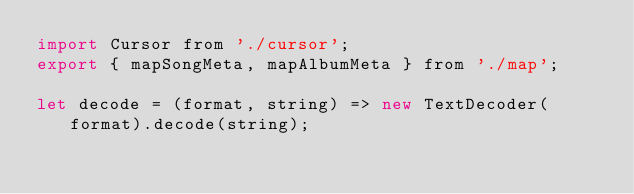Convert code to text. <code><loc_0><loc_0><loc_500><loc_500><_JavaScript_>import Cursor from './cursor';
export { mapSongMeta, mapAlbumMeta } from './map';

let decode = (format, string) => new TextDecoder(format).decode(string);
</code> 